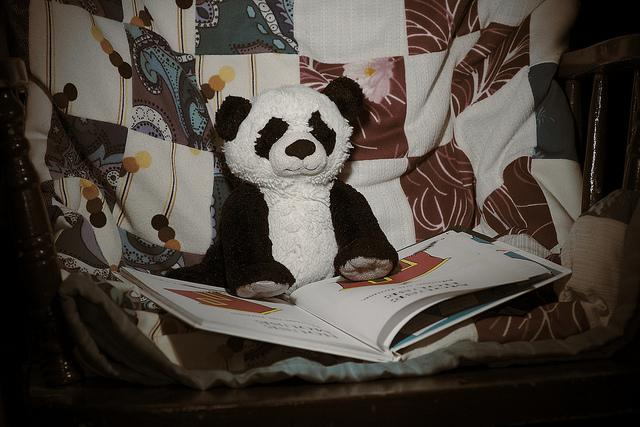Where do pandas come from? china 